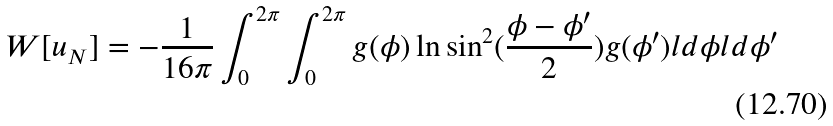<formula> <loc_0><loc_0><loc_500><loc_500>W [ u _ { N } ] = - { \frac { 1 } { 1 6 \pi } } \int _ { 0 } ^ { 2 \pi } \int _ { 0 } ^ { 2 \pi } g ( \phi ) \ln \sin ^ { 2 } ( { \frac { \phi - \phi ^ { \prime } } { 2 } } ) g ( \phi ^ { \prime } ) l d \phi l d \phi ^ { \prime }</formula> 